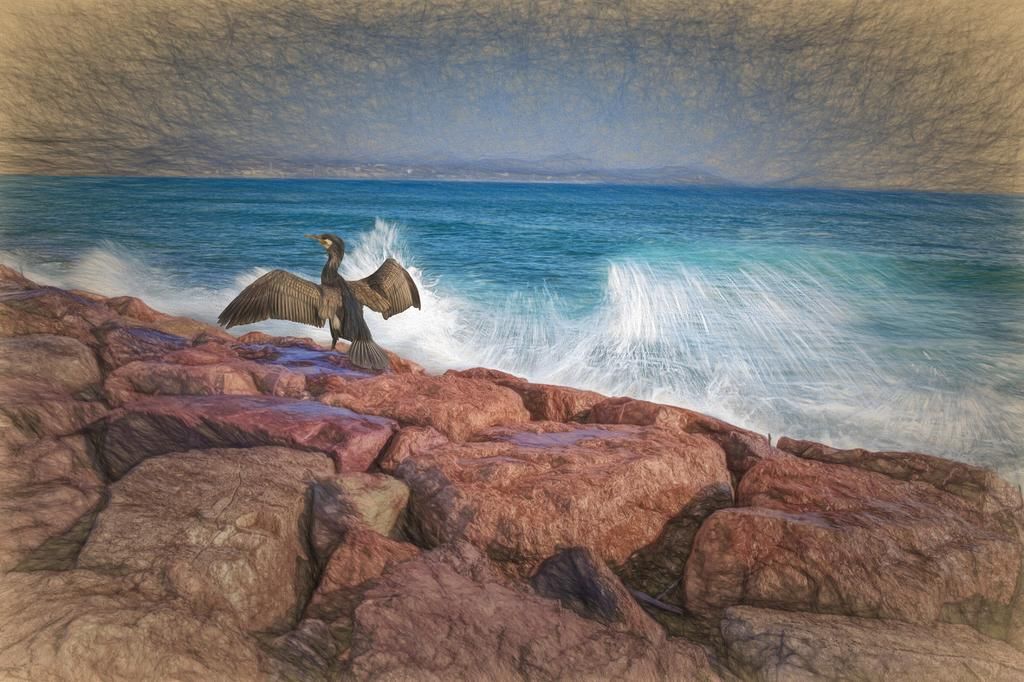What type of artwork is depicted in the image? The image is a painting. What animal can be seen in the painting? There is a duck in the painting. Where is the duck located in the painting? The duck is on rocks in the painting. What natural element is present in the painting? There is water in the painting. What type of vegetation is visible in the painting? There are trees in the painting. What type of quartz can be seen in the painting? There is no quartz present in the painting; it features a duck on rocks, water, and trees. What fact is being presented in the painting? The painting itself is not presenting a fact, but rather a scene featuring a duck, rocks, water, and trees. 